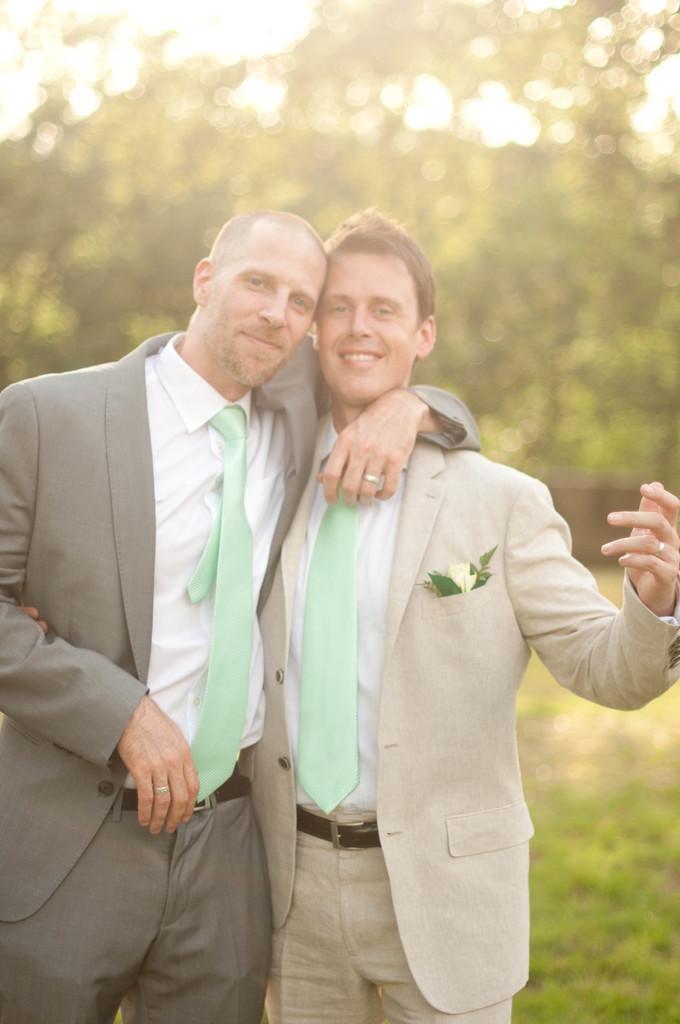How would you summarize this image in a sentence or two? In the foreground, I can see two persons are standing on grass. In the background, I can see trees and the sky. This picture might be taken in a park. 